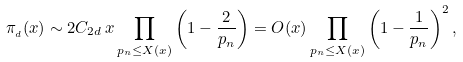Convert formula to latex. <formula><loc_0><loc_0><loc_500><loc_500>\pi _ { _ { d } } ( x ) \sim 2 { C } _ { 2 d } \, x \prod _ { p _ { n } \leq X ( x ) } \left ( 1 - \frac { 2 } { p _ { n } } \right ) = O ( x ) \prod _ { p _ { n } \leq X ( x ) } \left ( 1 - \frac { 1 } { p _ { n } } \right ) ^ { 2 } ,</formula> 